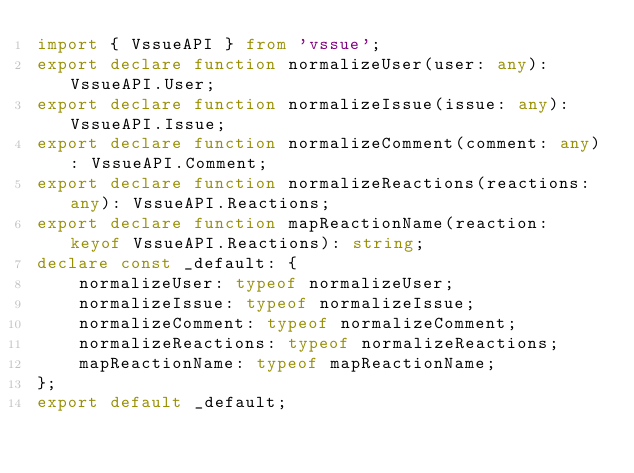Convert code to text. <code><loc_0><loc_0><loc_500><loc_500><_TypeScript_>import { VssueAPI } from 'vssue';
export declare function normalizeUser(user: any): VssueAPI.User;
export declare function normalizeIssue(issue: any): VssueAPI.Issue;
export declare function normalizeComment(comment: any): VssueAPI.Comment;
export declare function normalizeReactions(reactions: any): VssueAPI.Reactions;
export declare function mapReactionName(reaction: keyof VssueAPI.Reactions): string;
declare const _default: {
    normalizeUser: typeof normalizeUser;
    normalizeIssue: typeof normalizeIssue;
    normalizeComment: typeof normalizeComment;
    normalizeReactions: typeof normalizeReactions;
    mapReactionName: typeof mapReactionName;
};
export default _default;
</code> 